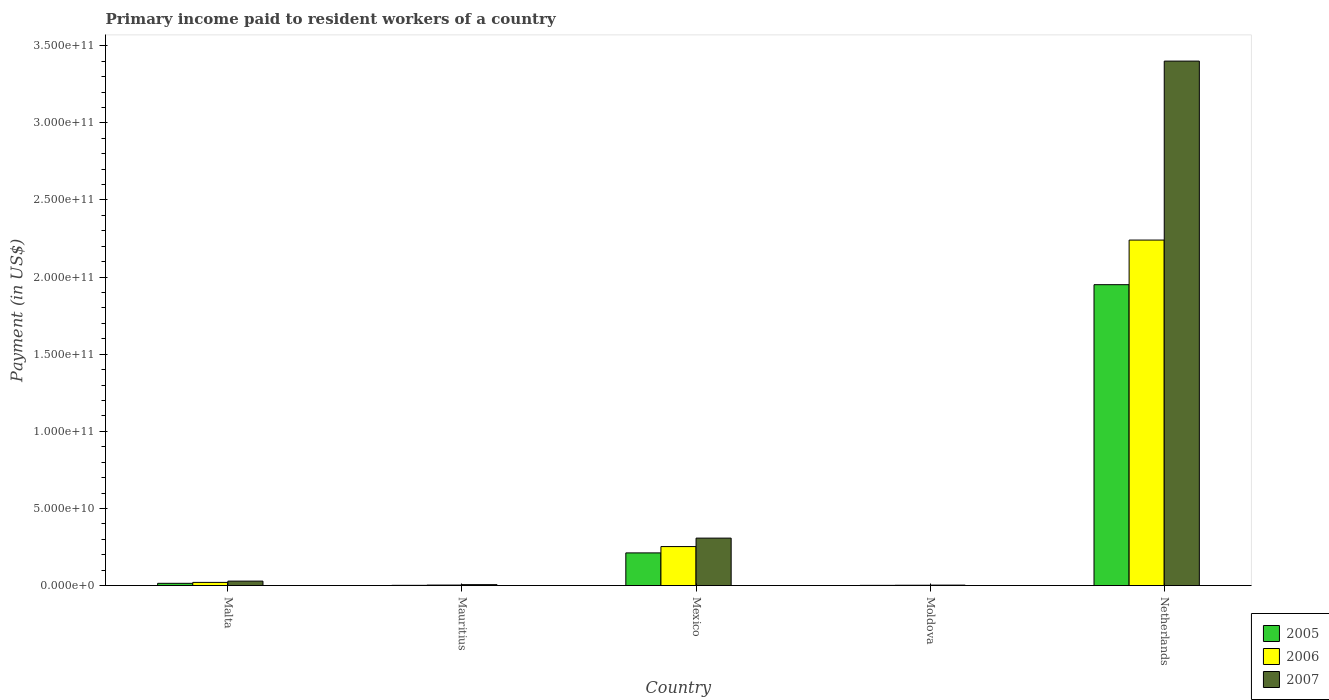How many groups of bars are there?
Your answer should be compact. 5. How many bars are there on the 1st tick from the left?
Your response must be concise. 3. How many bars are there on the 4th tick from the right?
Give a very brief answer. 3. What is the label of the 1st group of bars from the left?
Provide a succinct answer. Malta. What is the amount paid to workers in 2006 in Mexico?
Provide a succinct answer. 2.53e+1. Across all countries, what is the maximum amount paid to workers in 2006?
Give a very brief answer. 2.24e+11. Across all countries, what is the minimum amount paid to workers in 2005?
Make the answer very short. 1.28e+08. In which country was the amount paid to workers in 2005 minimum?
Your answer should be compact. Moldova. What is the total amount paid to workers in 2007 in the graph?
Provide a succinct answer. 3.75e+11. What is the difference between the amount paid to workers in 2007 in Malta and that in Mexico?
Provide a succinct answer. -2.79e+1. What is the difference between the amount paid to workers in 2006 in Moldova and the amount paid to workers in 2007 in Malta?
Make the answer very short. -2.68e+09. What is the average amount paid to workers in 2005 per country?
Keep it short and to the point. 4.36e+1. What is the difference between the amount paid to workers of/in 2006 and amount paid to workers of/in 2007 in Mauritius?
Offer a very short reply. -2.69e+08. What is the ratio of the amount paid to workers in 2007 in Mauritius to that in Netherlands?
Give a very brief answer. 0. Is the amount paid to workers in 2007 in Mauritius less than that in Netherlands?
Your answer should be compact. Yes. Is the difference between the amount paid to workers in 2006 in Mauritius and Moldova greater than the difference between the amount paid to workers in 2007 in Mauritius and Moldova?
Ensure brevity in your answer.  No. What is the difference between the highest and the second highest amount paid to workers in 2005?
Make the answer very short. 1.94e+11. What is the difference between the highest and the lowest amount paid to workers in 2006?
Keep it short and to the point. 2.24e+11. What does the 3rd bar from the left in Moldova represents?
Offer a very short reply. 2007. Is it the case that in every country, the sum of the amount paid to workers in 2005 and amount paid to workers in 2007 is greater than the amount paid to workers in 2006?
Make the answer very short. Yes. How many bars are there?
Offer a terse response. 15. How many countries are there in the graph?
Your answer should be compact. 5. What is the difference between two consecutive major ticks on the Y-axis?
Your answer should be compact. 5.00e+1. Are the values on the major ticks of Y-axis written in scientific E-notation?
Offer a terse response. Yes. Does the graph contain grids?
Your answer should be compact. No. How are the legend labels stacked?
Offer a terse response. Vertical. What is the title of the graph?
Give a very brief answer. Primary income paid to resident workers of a country. What is the label or title of the X-axis?
Offer a terse response. Country. What is the label or title of the Y-axis?
Your answer should be very brief. Payment (in US$). What is the Payment (in US$) in 2005 in Malta?
Provide a succinct answer. 1.45e+09. What is the Payment (in US$) of 2006 in Malta?
Ensure brevity in your answer.  2.05e+09. What is the Payment (in US$) in 2007 in Malta?
Ensure brevity in your answer.  2.88e+09. What is the Payment (in US$) of 2005 in Mauritius?
Make the answer very short. 1.51e+08. What is the Payment (in US$) in 2006 in Mauritius?
Your response must be concise. 3.24e+08. What is the Payment (in US$) in 2007 in Mauritius?
Provide a short and direct response. 5.93e+08. What is the Payment (in US$) in 2005 in Mexico?
Provide a short and direct response. 2.12e+1. What is the Payment (in US$) in 2006 in Mexico?
Your answer should be very brief. 2.53e+1. What is the Payment (in US$) in 2007 in Mexico?
Your answer should be very brief. 3.08e+1. What is the Payment (in US$) in 2005 in Moldova?
Keep it short and to the point. 1.28e+08. What is the Payment (in US$) in 2006 in Moldova?
Your answer should be compact. 2.03e+08. What is the Payment (in US$) in 2007 in Moldova?
Your answer should be very brief. 2.94e+08. What is the Payment (in US$) of 2005 in Netherlands?
Provide a short and direct response. 1.95e+11. What is the Payment (in US$) of 2006 in Netherlands?
Provide a succinct answer. 2.24e+11. What is the Payment (in US$) in 2007 in Netherlands?
Provide a short and direct response. 3.40e+11. Across all countries, what is the maximum Payment (in US$) of 2005?
Give a very brief answer. 1.95e+11. Across all countries, what is the maximum Payment (in US$) in 2006?
Keep it short and to the point. 2.24e+11. Across all countries, what is the maximum Payment (in US$) of 2007?
Offer a terse response. 3.40e+11. Across all countries, what is the minimum Payment (in US$) of 2005?
Your response must be concise. 1.28e+08. Across all countries, what is the minimum Payment (in US$) in 2006?
Your response must be concise. 2.03e+08. Across all countries, what is the minimum Payment (in US$) of 2007?
Offer a terse response. 2.94e+08. What is the total Payment (in US$) of 2005 in the graph?
Give a very brief answer. 2.18e+11. What is the total Payment (in US$) of 2006 in the graph?
Give a very brief answer. 2.52e+11. What is the total Payment (in US$) in 2007 in the graph?
Provide a short and direct response. 3.75e+11. What is the difference between the Payment (in US$) of 2005 in Malta and that in Mauritius?
Ensure brevity in your answer.  1.30e+09. What is the difference between the Payment (in US$) in 2006 in Malta and that in Mauritius?
Offer a terse response. 1.73e+09. What is the difference between the Payment (in US$) in 2007 in Malta and that in Mauritius?
Your answer should be compact. 2.29e+09. What is the difference between the Payment (in US$) in 2005 in Malta and that in Mexico?
Make the answer very short. -1.97e+1. What is the difference between the Payment (in US$) of 2006 in Malta and that in Mexico?
Your answer should be very brief. -2.32e+1. What is the difference between the Payment (in US$) of 2007 in Malta and that in Mexico?
Your answer should be very brief. -2.79e+1. What is the difference between the Payment (in US$) of 2005 in Malta and that in Moldova?
Your answer should be very brief. 1.33e+09. What is the difference between the Payment (in US$) of 2006 in Malta and that in Moldova?
Offer a terse response. 1.85e+09. What is the difference between the Payment (in US$) in 2007 in Malta and that in Moldova?
Make the answer very short. 2.59e+09. What is the difference between the Payment (in US$) in 2005 in Malta and that in Netherlands?
Keep it short and to the point. -1.94e+11. What is the difference between the Payment (in US$) in 2006 in Malta and that in Netherlands?
Your answer should be very brief. -2.22e+11. What is the difference between the Payment (in US$) of 2007 in Malta and that in Netherlands?
Provide a succinct answer. -3.37e+11. What is the difference between the Payment (in US$) of 2005 in Mauritius and that in Mexico?
Provide a succinct answer. -2.10e+1. What is the difference between the Payment (in US$) in 2006 in Mauritius and that in Mexico?
Your answer should be very brief. -2.50e+1. What is the difference between the Payment (in US$) of 2007 in Mauritius and that in Mexico?
Make the answer very short. -3.02e+1. What is the difference between the Payment (in US$) in 2005 in Mauritius and that in Moldova?
Keep it short and to the point. 2.30e+07. What is the difference between the Payment (in US$) of 2006 in Mauritius and that in Moldova?
Give a very brief answer. 1.20e+08. What is the difference between the Payment (in US$) of 2007 in Mauritius and that in Moldova?
Ensure brevity in your answer.  3.00e+08. What is the difference between the Payment (in US$) in 2005 in Mauritius and that in Netherlands?
Ensure brevity in your answer.  -1.95e+11. What is the difference between the Payment (in US$) in 2006 in Mauritius and that in Netherlands?
Offer a very short reply. -2.24e+11. What is the difference between the Payment (in US$) of 2007 in Mauritius and that in Netherlands?
Your answer should be compact. -3.39e+11. What is the difference between the Payment (in US$) of 2005 in Mexico and that in Moldova?
Ensure brevity in your answer.  2.11e+1. What is the difference between the Payment (in US$) of 2006 in Mexico and that in Moldova?
Make the answer very short. 2.51e+1. What is the difference between the Payment (in US$) in 2007 in Mexico and that in Moldova?
Your answer should be compact. 3.05e+1. What is the difference between the Payment (in US$) in 2005 in Mexico and that in Netherlands?
Offer a terse response. -1.74e+11. What is the difference between the Payment (in US$) of 2006 in Mexico and that in Netherlands?
Offer a terse response. -1.99e+11. What is the difference between the Payment (in US$) of 2007 in Mexico and that in Netherlands?
Give a very brief answer. -3.09e+11. What is the difference between the Payment (in US$) in 2005 in Moldova and that in Netherlands?
Ensure brevity in your answer.  -1.95e+11. What is the difference between the Payment (in US$) of 2006 in Moldova and that in Netherlands?
Give a very brief answer. -2.24e+11. What is the difference between the Payment (in US$) in 2007 in Moldova and that in Netherlands?
Keep it short and to the point. -3.40e+11. What is the difference between the Payment (in US$) of 2005 in Malta and the Payment (in US$) of 2006 in Mauritius?
Your answer should be compact. 1.13e+09. What is the difference between the Payment (in US$) in 2005 in Malta and the Payment (in US$) in 2007 in Mauritius?
Offer a terse response. 8.62e+08. What is the difference between the Payment (in US$) in 2006 in Malta and the Payment (in US$) in 2007 in Mauritius?
Give a very brief answer. 1.46e+09. What is the difference between the Payment (in US$) of 2005 in Malta and the Payment (in US$) of 2006 in Mexico?
Your response must be concise. -2.38e+1. What is the difference between the Payment (in US$) in 2005 in Malta and the Payment (in US$) in 2007 in Mexico?
Keep it short and to the point. -2.93e+1. What is the difference between the Payment (in US$) in 2006 in Malta and the Payment (in US$) in 2007 in Mexico?
Give a very brief answer. -2.87e+1. What is the difference between the Payment (in US$) in 2005 in Malta and the Payment (in US$) in 2006 in Moldova?
Keep it short and to the point. 1.25e+09. What is the difference between the Payment (in US$) in 2005 in Malta and the Payment (in US$) in 2007 in Moldova?
Your answer should be compact. 1.16e+09. What is the difference between the Payment (in US$) of 2006 in Malta and the Payment (in US$) of 2007 in Moldova?
Make the answer very short. 1.76e+09. What is the difference between the Payment (in US$) in 2005 in Malta and the Payment (in US$) in 2006 in Netherlands?
Ensure brevity in your answer.  -2.23e+11. What is the difference between the Payment (in US$) in 2005 in Malta and the Payment (in US$) in 2007 in Netherlands?
Your response must be concise. -3.39e+11. What is the difference between the Payment (in US$) in 2006 in Malta and the Payment (in US$) in 2007 in Netherlands?
Provide a succinct answer. -3.38e+11. What is the difference between the Payment (in US$) in 2005 in Mauritius and the Payment (in US$) in 2006 in Mexico?
Provide a succinct answer. -2.51e+1. What is the difference between the Payment (in US$) in 2005 in Mauritius and the Payment (in US$) in 2007 in Mexico?
Provide a short and direct response. -3.06e+1. What is the difference between the Payment (in US$) in 2006 in Mauritius and the Payment (in US$) in 2007 in Mexico?
Give a very brief answer. -3.04e+1. What is the difference between the Payment (in US$) in 2005 in Mauritius and the Payment (in US$) in 2006 in Moldova?
Keep it short and to the point. -5.20e+07. What is the difference between the Payment (in US$) in 2005 in Mauritius and the Payment (in US$) in 2007 in Moldova?
Make the answer very short. -1.42e+08. What is the difference between the Payment (in US$) in 2006 in Mauritius and the Payment (in US$) in 2007 in Moldova?
Offer a terse response. 3.02e+07. What is the difference between the Payment (in US$) in 2005 in Mauritius and the Payment (in US$) in 2006 in Netherlands?
Keep it short and to the point. -2.24e+11. What is the difference between the Payment (in US$) of 2005 in Mauritius and the Payment (in US$) of 2007 in Netherlands?
Provide a short and direct response. -3.40e+11. What is the difference between the Payment (in US$) of 2006 in Mauritius and the Payment (in US$) of 2007 in Netherlands?
Your response must be concise. -3.40e+11. What is the difference between the Payment (in US$) of 2005 in Mexico and the Payment (in US$) of 2006 in Moldova?
Your answer should be compact. 2.10e+1. What is the difference between the Payment (in US$) of 2005 in Mexico and the Payment (in US$) of 2007 in Moldova?
Give a very brief answer. 2.09e+1. What is the difference between the Payment (in US$) of 2006 in Mexico and the Payment (in US$) of 2007 in Moldova?
Give a very brief answer. 2.50e+1. What is the difference between the Payment (in US$) in 2005 in Mexico and the Payment (in US$) in 2006 in Netherlands?
Your answer should be very brief. -2.03e+11. What is the difference between the Payment (in US$) of 2005 in Mexico and the Payment (in US$) of 2007 in Netherlands?
Ensure brevity in your answer.  -3.19e+11. What is the difference between the Payment (in US$) of 2006 in Mexico and the Payment (in US$) of 2007 in Netherlands?
Make the answer very short. -3.15e+11. What is the difference between the Payment (in US$) in 2005 in Moldova and the Payment (in US$) in 2006 in Netherlands?
Give a very brief answer. -2.24e+11. What is the difference between the Payment (in US$) in 2005 in Moldova and the Payment (in US$) in 2007 in Netherlands?
Keep it short and to the point. -3.40e+11. What is the difference between the Payment (in US$) in 2006 in Moldova and the Payment (in US$) in 2007 in Netherlands?
Ensure brevity in your answer.  -3.40e+11. What is the average Payment (in US$) in 2005 per country?
Give a very brief answer. 4.36e+1. What is the average Payment (in US$) in 2006 per country?
Your response must be concise. 5.04e+1. What is the average Payment (in US$) of 2007 per country?
Make the answer very short. 7.49e+1. What is the difference between the Payment (in US$) in 2005 and Payment (in US$) in 2006 in Malta?
Your response must be concise. -5.99e+08. What is the difference between the Payment (in US$) in 2005 and Payment (in US$) in 2007 in Malta?
Offer a terse response. -1.42e+09. What is the difference between the Payment (in US$) in 2006 and Payment (in US$) in 2007 in Malta?
Your response must be concise. -8.25e+08. What is the difference between the Payment (in US$) of 2005 and Payment (in US$) of 2006 in Mauritius?
Keep it short and to the point. -1.72e+08. What is the difference between the Payment (in US$) in 2005 and Payment (in US$) in 2007 in Mauritius?
Your answer should be compact. -4.42e+08. What is the difference between the Payment (in US$) in 2006 and Payment (in US$) in 2007 in Mauritius?
Your answer should be very brief. -2.69e+08. What is the difference between the Payment (in US$) in 2005 and Payment (in US$) in 2006 in Mexico?
Ensure brevity in your answer.  -4.10e+09. What is the difference between the Payment (in US$) in 2005 and Payment (in US$) in 2007 in Mexico?
Offer a terse response. -9.58e+09. What is the difference between the Payment (in US$) in 2006 and Payment (in US$) in 2007 in Mexico?
Your answer should be very brief. -5.48e+09. What is the difference between the Payment (in US$) of 2005 and Payment (in US$) of 2006 in Moldova?
Ensure brevity in your answer.  -7.50e+07. What is the difference between the Payment (in US$) of 2005 and Payment (in US$) of 2007 in Moldova?
Offer a very short reply. -1.65e+08. What is the difference between the Payment (in US$) in 2006 and Payment (in US$) in 2007 in Moldova?
Offer a very short reply. -9.03e+07. What is the difference between the Payment (in US$) of 2005 and Payment (in US$) of 2006 in Netherlands?
Offer a very short reply. -2.89e+1. What is the difference between the Payment (in US$) of 2005 and Payment (in US$) of 2007 in Netherlands?
Your answer should be compact. -1.45e+11. What is the difference between the Payment (in US$) of 2006 and Payment (in US$) of 2007 in Netherlands?
Give a very brief answer. -1.16e+11. What is the ratio of the Payment (in US$) in 2005 in Malta to that in Mauritius?
Your answer should be very brief. 9.61. What is the ratio of the Payment (in US$) of 2006 in Malta to that in Mauritius?
Provide a succinct answer. 6.34. What is the ratio of the Payment (in US$) in 2007 in Malta to that in Mauritius?
Your answer should be very brief. 4.85. What is the ratio of the Payment (in US$) in 2005 in Malta to that in Mexico?
Provide a succinct answer. 0.07. What is the ratio of the Payment (in US$) of 2006 in Malta to that in Mexico?
Your answer should be very brief. 0.08. What is the ratio of the Payment (in US$) in 2007 in Malta to that in Mexico?
Keep it short and to the point. 0.09. What is the ratio of the Payment (in US$) of 2005 in Malta to that in Moldova?
Make the answer very short. 11.33. What is the ratio of the Payment (in US$) of 2006 in Malta to that in Moldova?
Provide a succinct answer. 10.1. What is the ratio of the Payment (in US$) of 2007 in Malta to that in Moldova?
Make the answer very short. 9.8. What is the ratio of the Payment (in US$) in 2005 in Malta to that in Netherlands?
Provide a succinct answer. 0.01. What is the ratio of the Payment (in US$) of 2006 in Malta to that in Netherlands?
Keep it short and to the point. 0.01. What is the ratio of the Payment (in US$) of 2007 in Malta to that in Netherlands?
Offer a very short reply. 0.01. What is the ratio of the Payment (in US$) of 2005 in Mauritius to that in Mexico?
Give a very brief answer. 0.01. What is the ratio of the Payment (in US$) in 2006 in Mauritius to that in Mexico?
Your answer should be very brief. 0.01. What is the ratio of the Payment (in US$) of 2007 in Mauritius to that in Mexico?
Provide a short and direct response. 0.02. What is the ratio of the Payment (in US$) of 2005 in Mauritius to that in Moldova?
Your answer should be compact. 1.18. What is the ratio of the Payment (in US$) of 2006 in Mauritius to that in Moldova?
Provide a short and direct response. 1.59. What is the ratio of the Payment (in US$) in 2007 in Mauritius to that in Moldova?
Your response must be concise. 2.02. What is the ratio of the Payment (in US$) in 2005 in Mauritius to that in Netherlands?
Give a very brief answer. 0. What is the ratio of the Payment (in US$) in 2006 in Mauritius to that in Netherlands?
Offer a terse response. 0. What is the ratio of the Payment (in US$) in 2007 in Mauritius to that in Netherlands?
Offer a very short reply. 0. What is the ratio of the Payment (in US$) in 2005 in Mexico to that in Moldova?
Offer a terse response. 164.99. What is the ratio of the Payment (in US$) of 2006 in Mexico to that in Moldova?
Offer a very short reply. 124.33. What is the ratio of the Payment (in US$) of 2007 in Mexico to that in Moldova?
Your answer should be very brief. 104.75. What is the ratio of the Payment (in US$) of 2005 in Mexico to that in Netherlands?
Keep it short and to the point. 0.11. What is the ratio of the Payment (in US$) of 2006 in Mexico to that in Netherlands?
Make the answer very short. 0.11. What is the ratio of the Payment (in US$) in 2007 in Mexico to that in Netherlands?
Provide a short and direct response. 0.09. What is the ratio of the Payment (in US$) of 2005 in Moldova to that in Netherlands?
Your response must be concise. 0. What is the ratio of the Payment (in US$) in 2006 in Moldova to that in Netherlands?
Your response must be concise. 0. What is the ratio of the Payment (in US$) of 2007 in Moldova to that in Netherlands?
Offer a terse response. 0. What is the difference between the highest and the second highest Payment (in US$) of 2005?
Keep it short and to the point. 1.74e+11. What is the difference between the highest and the second highest Payment (in US$) of 2006?
Make the answer very short. 1.99e+11. What is the difference between the highest and the second highest Payment (in US$) in 2007?
Offer a terse response. 3.09e+11. What is the difference between the highest and the lowest Payment (in US$) in 2005?
Your answer should be very brief. 1.95e+11. What is the difference between the highest and the lowest Payment (in US$) in 2006?
Give a very brief answer. 2.24e+11. What is the difference between the highest and the lowest Payment (in US$) of 2007?
Provide a short and direct response. 3.40e+11. 